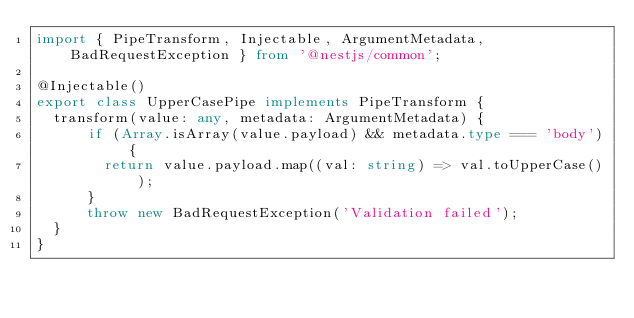<code> <loc_0><loc_0><loc_500><loc_500><_TypeScript_>import { PipeTransform, Injectable, ArgumentMetadata, BadRequestException } from '@nestjs/common';

@Injectable()
export class UpperCasePipe implements PipeTransform {
  transform(value: any, metadata: ArgumentMetadata) {
      if (Array.isArray(value.payload) && metadata.type === 'body') {
        return value.payload.map((val: string) => val.toUpperCase());
      }
      throw new BadRequestException('Validation failed');
  }
}
</code> 